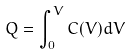Convert formula to latex. <formula><loc_0><loc_0><loc_500><loc_500>Q = \int _ { 0 } ^ { V } C ( V ) d V</formula> 